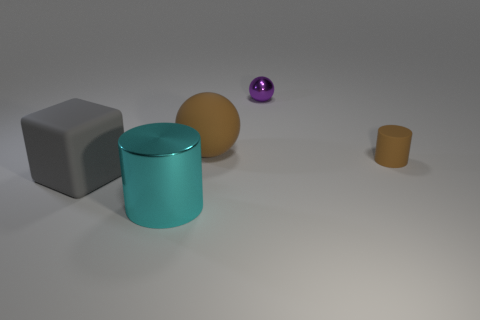Add 2 large cyan objects. How many objects exist? 7 Subtract all purple spheres. How many spheres are left? 1 Subtract 0 gray cylinders. How many objects are left? 5 Subtract all spheres. How many objects are left? 3 Subtract 1 cylinders. How many cylinders are left? 1 Subtract all red cubes. Subtract all brown cylinders. How many cubes are left? 1 Subtract all gray cylinders. How many brown cubes are left? 0 Subtract all tiny rubber cylinders. Subtract all tiny blue rubber objects. How many objects are left? 4 Add 4 large blocks. How many large blocks are left? 5 Add 5 purple balls. How many purple balls exist? 6 